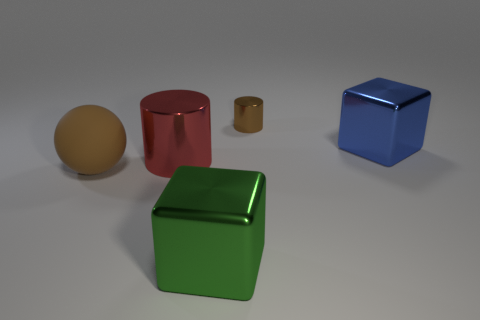Is the color of the tiny metallic thing the same as the rubber sphere?
Your answer should be compact. Yes. What is the color of the other metal object that is the same shape as the large red metallic thing?
Provide a succinct answer. Brown. What number of other metal cylinders are the same color as the small cylinder?
Provide a short and direct response. 0. Is there any other thing that has the same shape as the tiny shiny thing?
Give a very brief answer. Yes. There is a metal thing that is in front of the large red shiny cylinder that is behind the rubber sphere; is there a block that is to the right of it?
Your answer should be very brief. Yes. What number of green things are made of the same material as the red thing?
Provide a short and direct response. 1. There is a metallic object that is on the right side of the small brown shiny cylinder; is it the same size as the metallic object that is on the left side of the green metallic object?
Offer a terse response. Yes. The metallic object behind the big block on the right side of the cube that is in front of the big metal cylinder is what color?
Give a very brief answer. Brown. Is there a tiny red object that has the same shape as the green thing?
Ensure brevity in your answer.  No. Are there the same number of blue metallic things that are to the left of the big red cylinder and big cubes that are behind the large matte ball?
Your response must be concise. No. 